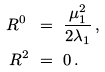Convert formula to latex. <formula><loc_0><loc_0><loc_500><loc_500>R ^ { 0 } \ & = \ \frac { \mu _ { 1 } ^ { 2 } } { 2 \lambda _ { 1 } } \, , \\ R ^ { 2 } \ & = \ 0 \, .</formula> 